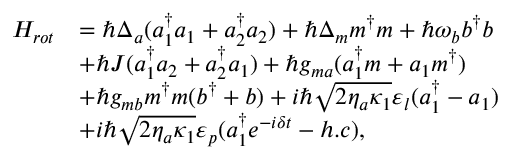Convert formula to latex. <formula><loc_0><loc_0><loc_500><loc_500>\begin{array} { r l } { H _ { r o t } } & { = \hbar { \Delta } _ { a } ( a _ { 1 } ^ { \dagger } a _ { 1 } + a _ { 2 } ^ { \dagger } a _ { 2 } ) + \hbar { \Delta } _ { m } m ^ { \dagger } m + \hbar { \omega } _ { b } b ^ { \dagger } b } \\ & { + \hbar { J } ( a _ { 1 } ^ { \dagger } a _ { 2 } + a _ { 2 } ^ { \dagger } a _ { 1 } ) + \hbar { g } _ { m a } ( a _ { 1 } ^ { \dagger } m + a _ { 1 } m ^ { \dagger } ) } \\ & { + \hslash g _ { m b } m ^ { \dagger } m ( b ^ { \dagger } + b ) + i \hbar { \sqrt } { 2 \eta _ { a } \kappa _ { 1 } } \varepsilon _ { l } ( a _ { 1 } ^ { \dagger } - a _ { 1 } ) } \\ & { + i \hbar { \sqrt } { 2 \eta _ { a } \kappa _ { 1 } } \varepsilon _ { p } ( a _ { 1 } ^ { \dagger } e ^ { - i \delta t } - h . c ) , } \end{array}</formula> 